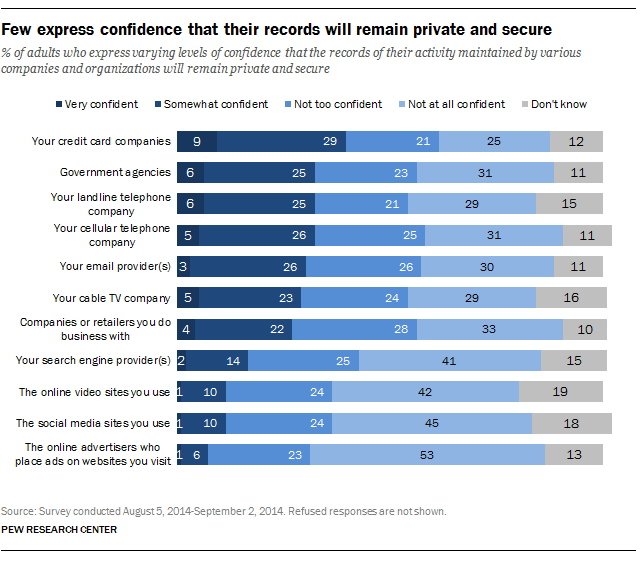Give some essential details in this illustration. The highest value of the grey bars was 0.19. According to the survey, a smaller proportion of respondents expressed high confidence in credit card companies (16%) compared to those who were not confident at all (0.16%). 